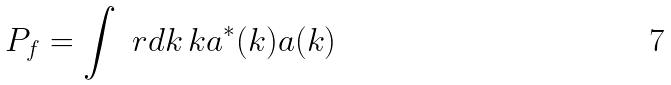<formula> <loc_0><loc_0><loc_500><loc_500>P _ { f } = \int \ r d k \, k a ^ { * } ( k ) a ( k )</formula> 